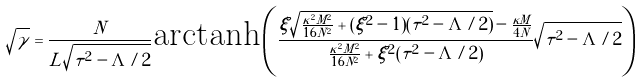Convert formula to latex. <formula><loc_0><loc_0><loc_500><loc_500>\sqrt { \gamma } = \frac { N } { L \sqrt { \tau ^ { 2 } - \Lambda / 2 } } \text {arctanh} \left ( \frac { \xi \sqrt { \frac { \kappa ^ { 2 } M ^ { 2 } } { 1 6 N ^ { 2 } } + ( \xi ^ { 2 } - 1 ) ( \tau ^ { 2 } - \Lambda / 2 ) } - \frac { \kappa M } { 4 N } } { \frac { \kappa ^ { 2 } M ^ { 2 } } { 1 6 N ^ { 2 } } + \xi ^ { 2 } ( \tau ^ { 2 } - \Lambda / 2 ) } \sqrt { \tau ^ { 2 } - \Lambda / 2 } \right )</formula> 